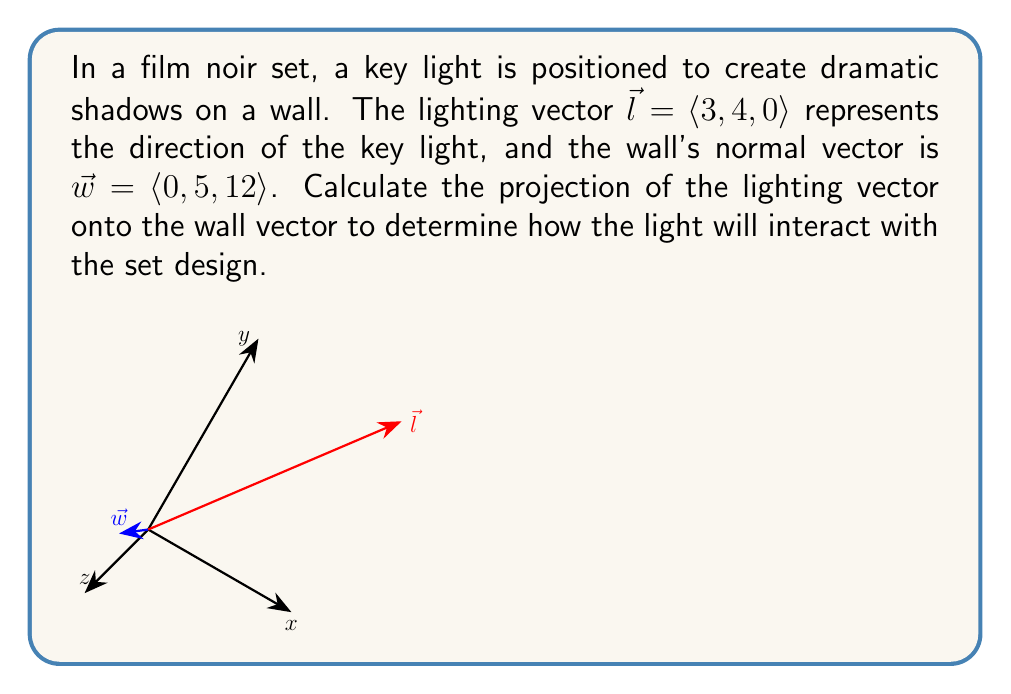Teach me how to tackle this problem. To find the projection of $\vec{l}$ onto $\vec{w}$, we'll use the vector projection formula:

$$\text{proj}_{\vec{w}}\vec{l} = \frac{\vec{l} \cdot \vec{w}}{\|\vec{w}\|^2} \vec{w}$$

Step 1: Calculate the dot product $\vec{l} \cdot \vec{w}$
$$\vec{l} \cdot \vec{w} = 3(0) + 4(5) + 0(12) = 20$$

Step 2: Calculate the magnitude of $\vec{w}$ squared
$$\|\vec{w}\|^2 = 0^2 + 5^2 + 12^2 = 25 + 144 = 169$$

Step 3: Calculate the scalar projection
$$\frac{\vec{l} \cdot \vec{w}}{\|\vec{w}\|^2} = \frac{20}{169}$$

Step 4: Multiply the scalar projection by $\vec{w}$
$$\text{proj}_{\vec{w}}\vec{l} = \frac{20}{169} \langle 0, 5, 12 \rangle = \left\langle 0, \frac{100}{169}, \frac{240}{169} \right\rangle$$

This vector represents how the lighting will interact with the wall, affecting the shadows and overall mood of the scene.
Answer: $\left\langle 0, \frac{100}{169}, \frac{240}{169} \right\rangle$ 